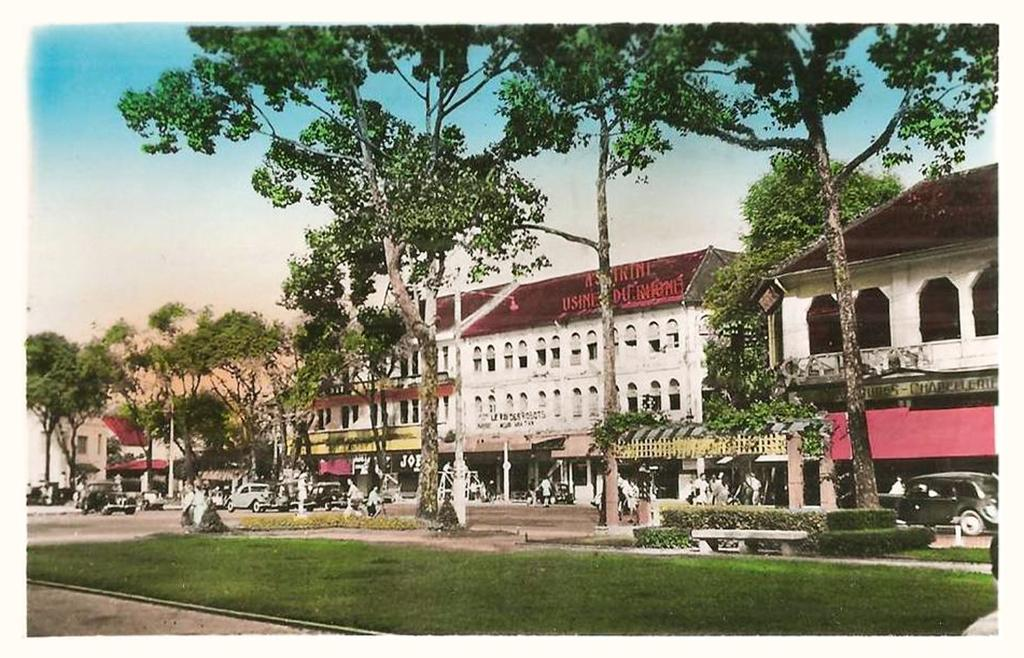Who or what can be seen in the image? There are people in the image. What else is visible on the road in the image? There are vehicles on the road in the image. What structures can be seen in the background of the image? There are buildings visible in the image. What type of vegetation is present in the image? Trees are present in the image. What is the ground surface like in the image? Grass is visible in the image. What type of punishment is being given to the trees in the image? There is no punishment being given to the trees in the image; they are simply present as part of the natural environment. 